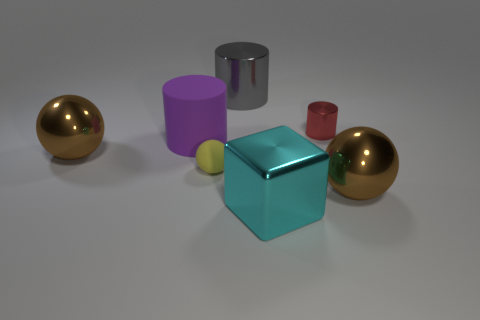Add 3 small yellow objects. How many objects exist? 10 Subtract all cubes. How many objects are left? 6 Subtract 0 yellow cubes. How many objects are left? 7 Subtract all large matte cylinders. Subtract all large yellow things. How many objects are left? 6 Add 4 big blocks. How many big blocks are left? 5 Add 6 shiny spheres. How many shiny spheres exist? 8 